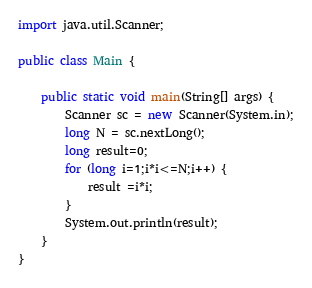<code> <loc_0><loc_0><loc_500><loc_500><_Java_>import java.util.Scanner;

public class Main {

	public static void main(String[] args) {
		Scanner sc = new Scanner(System.in);
		long N = sc.nextLong();
		long result=0;
		for (long i=1;i*i<=N;i++) {
			result =i*i;
		}
		System.out.println(result);
	}
}</code> 